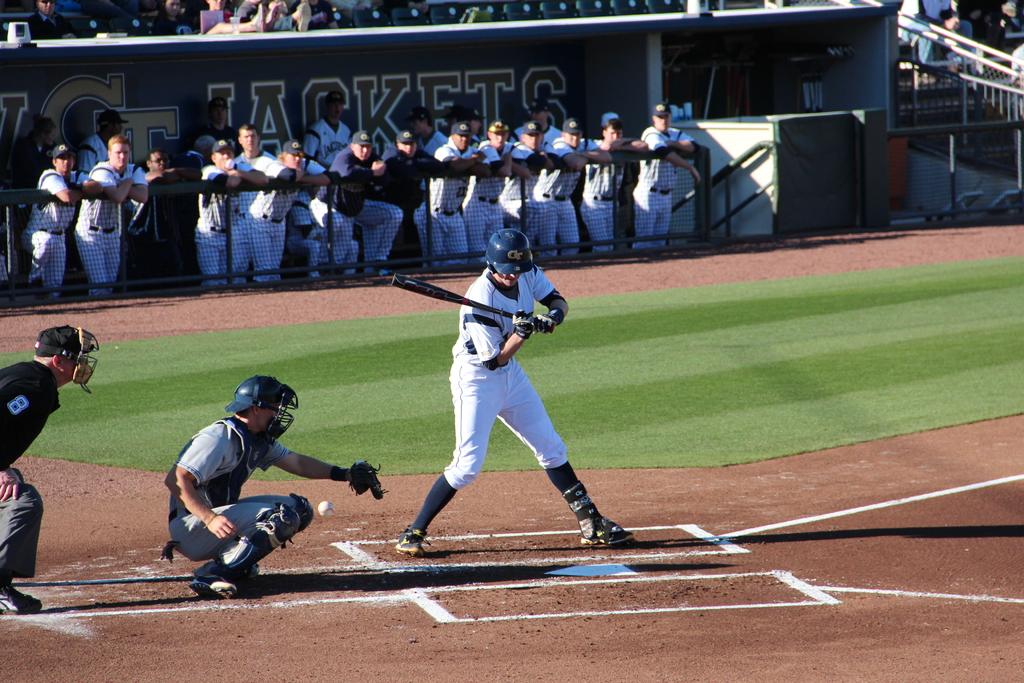What is the team name in the dugout?
Make the answer very short. Jackets. What is the umpire's number?
Your answer should be very brief. 8. 